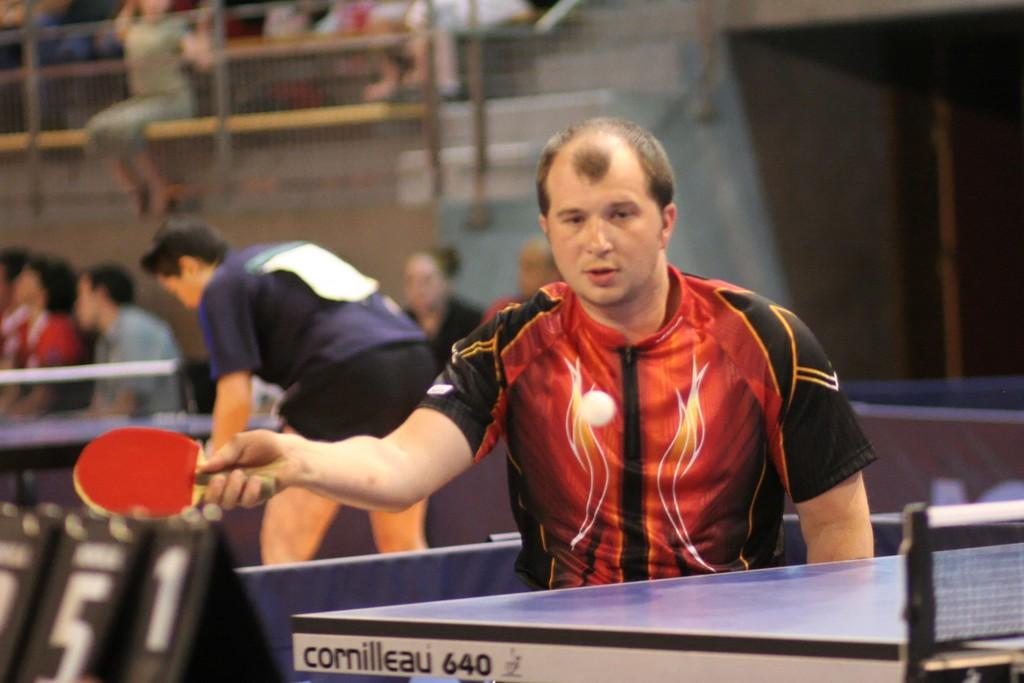Who is present in the image? There is a person in the image. What is the person holding in the image? The person is holding a table tennis racket. What is in front of the person in the image? There is a table tennis table in front of the person. What can be seen in the background of the image? There are people and objects in the background of the image. What type of juice is the woman drinking in the image? There is no woman or juice present in the image. 